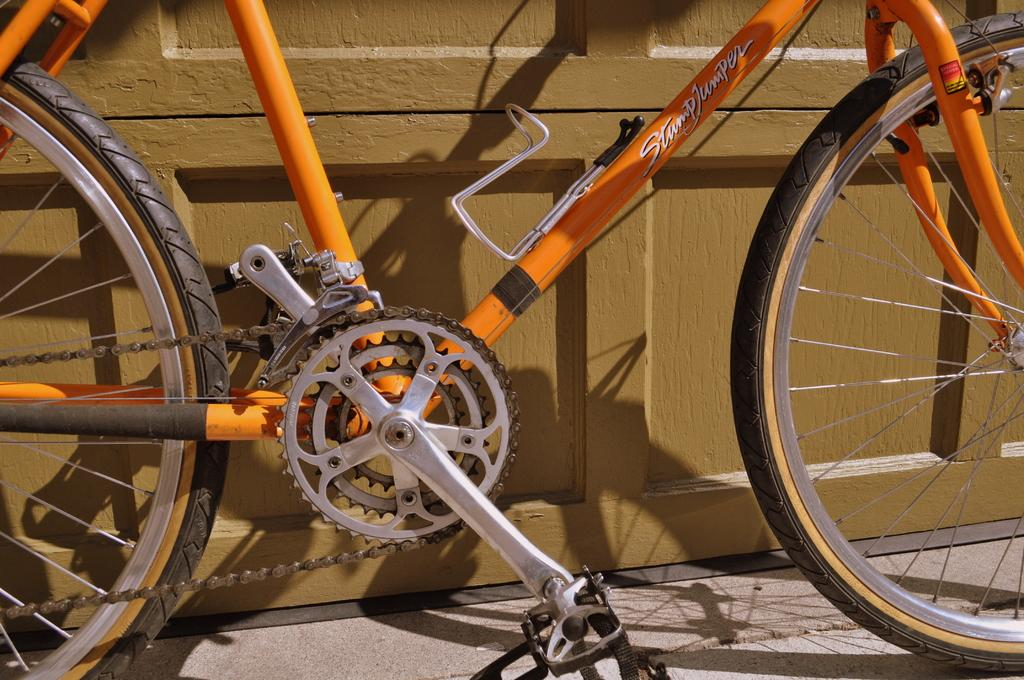What is the main object in the image? There is a bicycle in the image. Where is the bicycle located? The bicycle is on the sidewalk. What else can be seen in the image? There is a wooden door in the image. What color is the bicycle? The bicycle is orange in color. Can you tell me when the bicycle was born in the image? Bicycles do not have a birth date, so this question cannot be answered. 